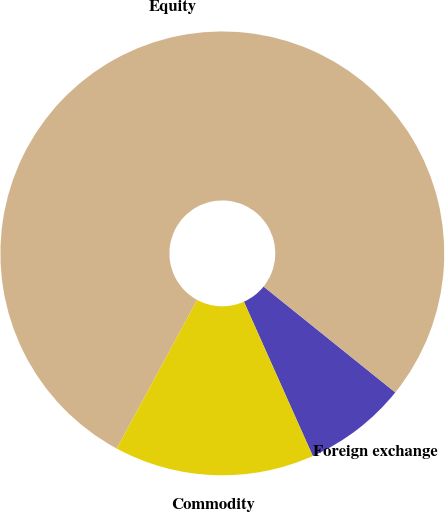Convert chart to OTSL. <chart><loc_0><loc_0><loc_500><loc_500><pie_chart><fcel>Foreign exchange<fcel>Equity<fcel>Commodity<nl><fcel>7.54%<fcel>77.88%<fcel>14.58%<nl></chart> 